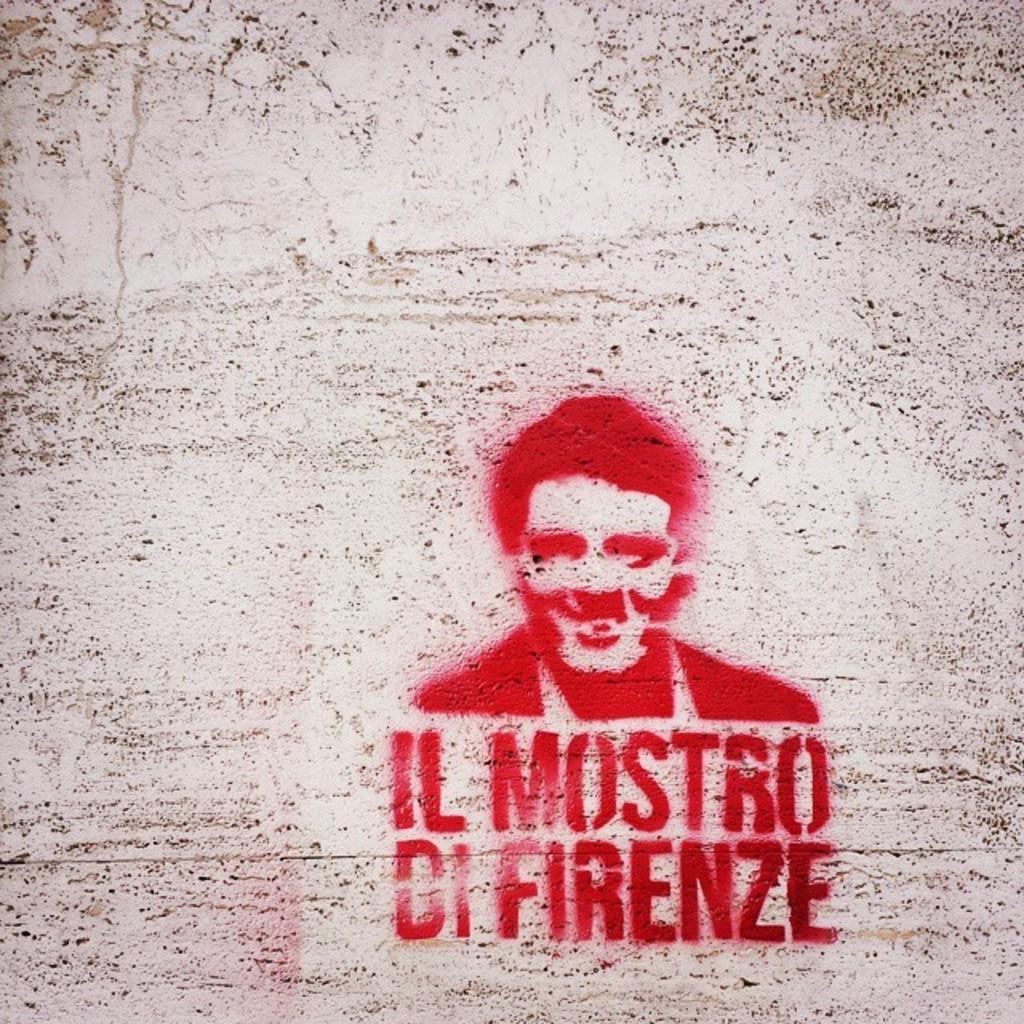In one or two sentences, can you explain what this image depicts? In this image on the wall there is a painting with some text written on it. 